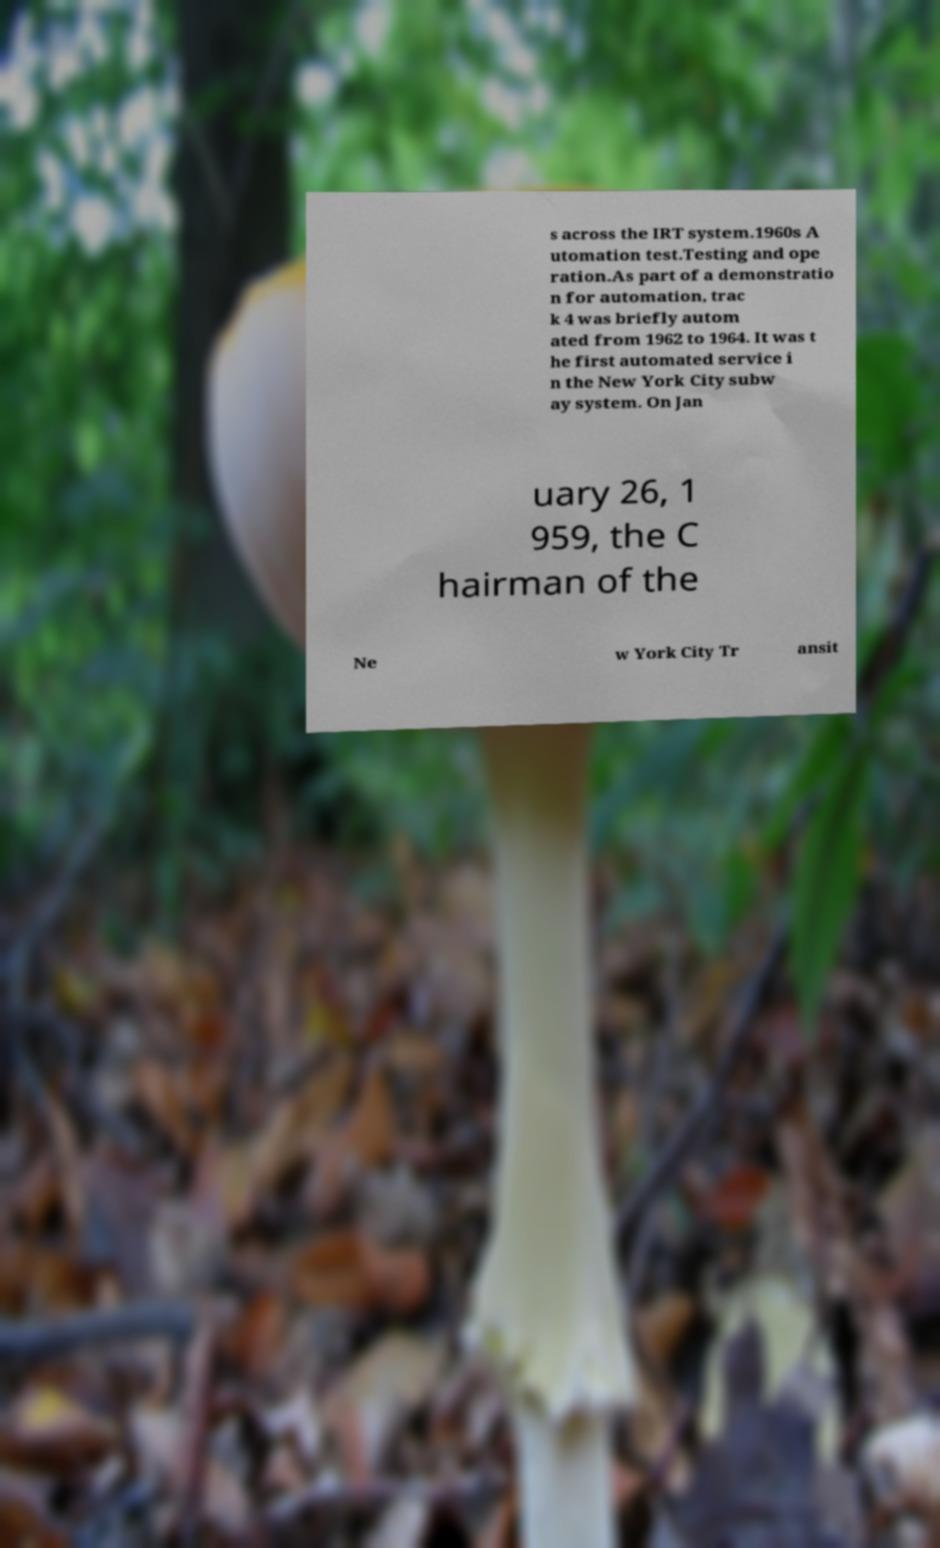Please read and relay the text visible in this image. What does it say? s across the IRT system.1960s A utomation test.Testing and ope ration.As part of a demonstratio n for automation, trac k 4 was briefly autom ated from 1962 to 1964. It was t he first automated service i n the New York City subw ay system. On Jan uary 26, 1 959, the C hairman of the Ne w York City Tr ansit 